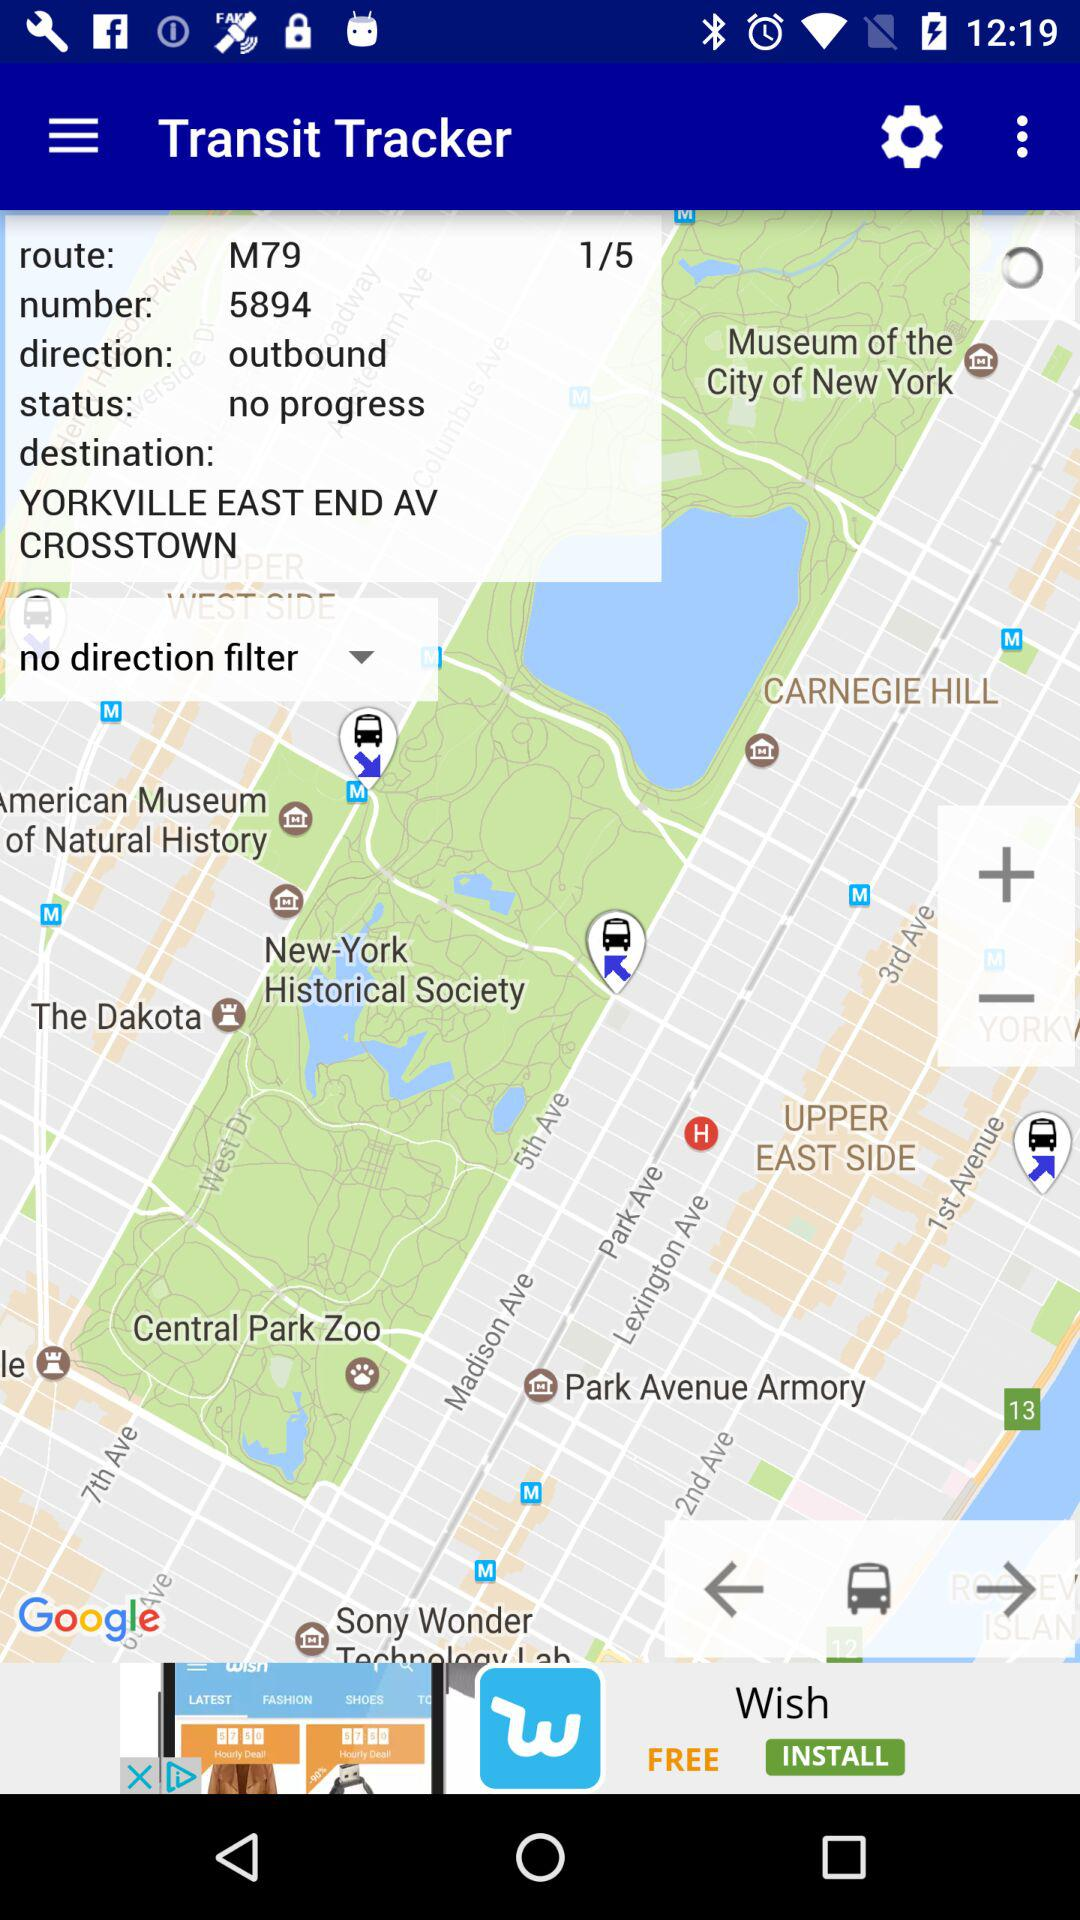What's the status? The status is "no progress". 